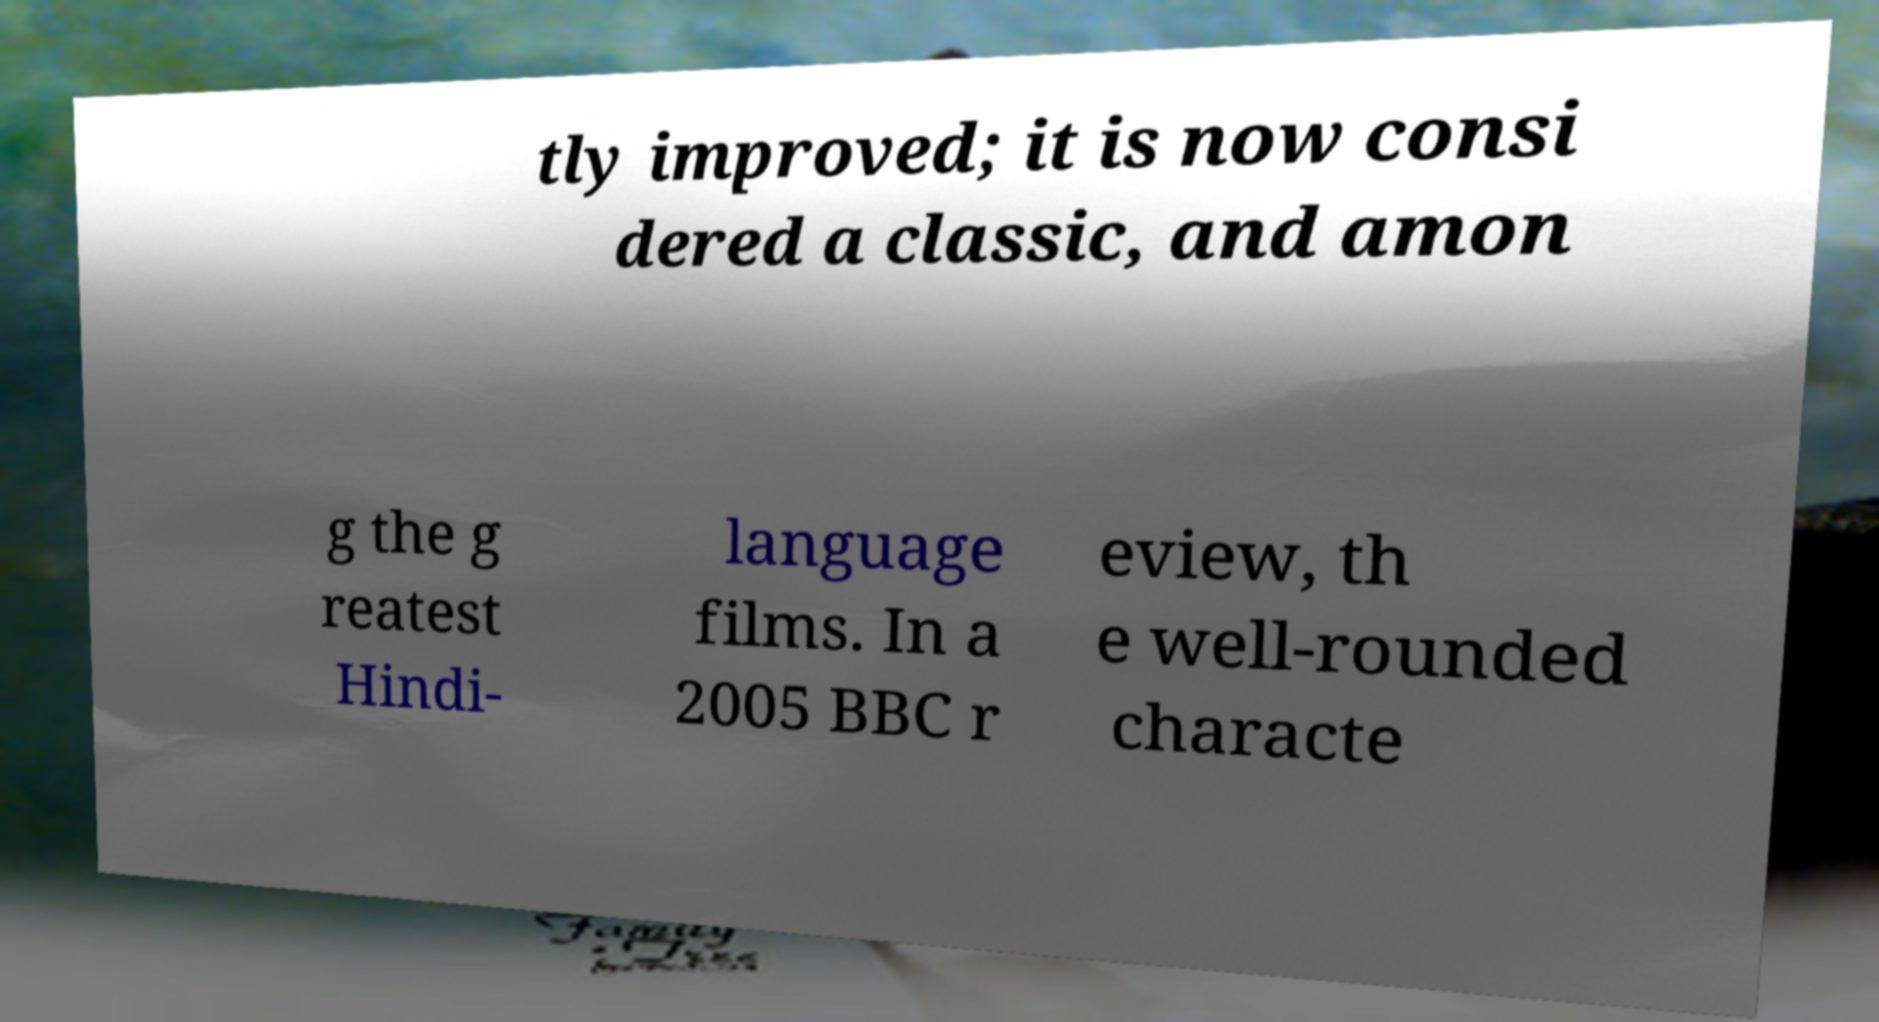Please read and relay the text visible in this image. What does it say? tly improved; it is now consi dered a classic, and amon g the g reatest Hindi- language films. In a 2005 BBC r eview, th e well-rounded characte 